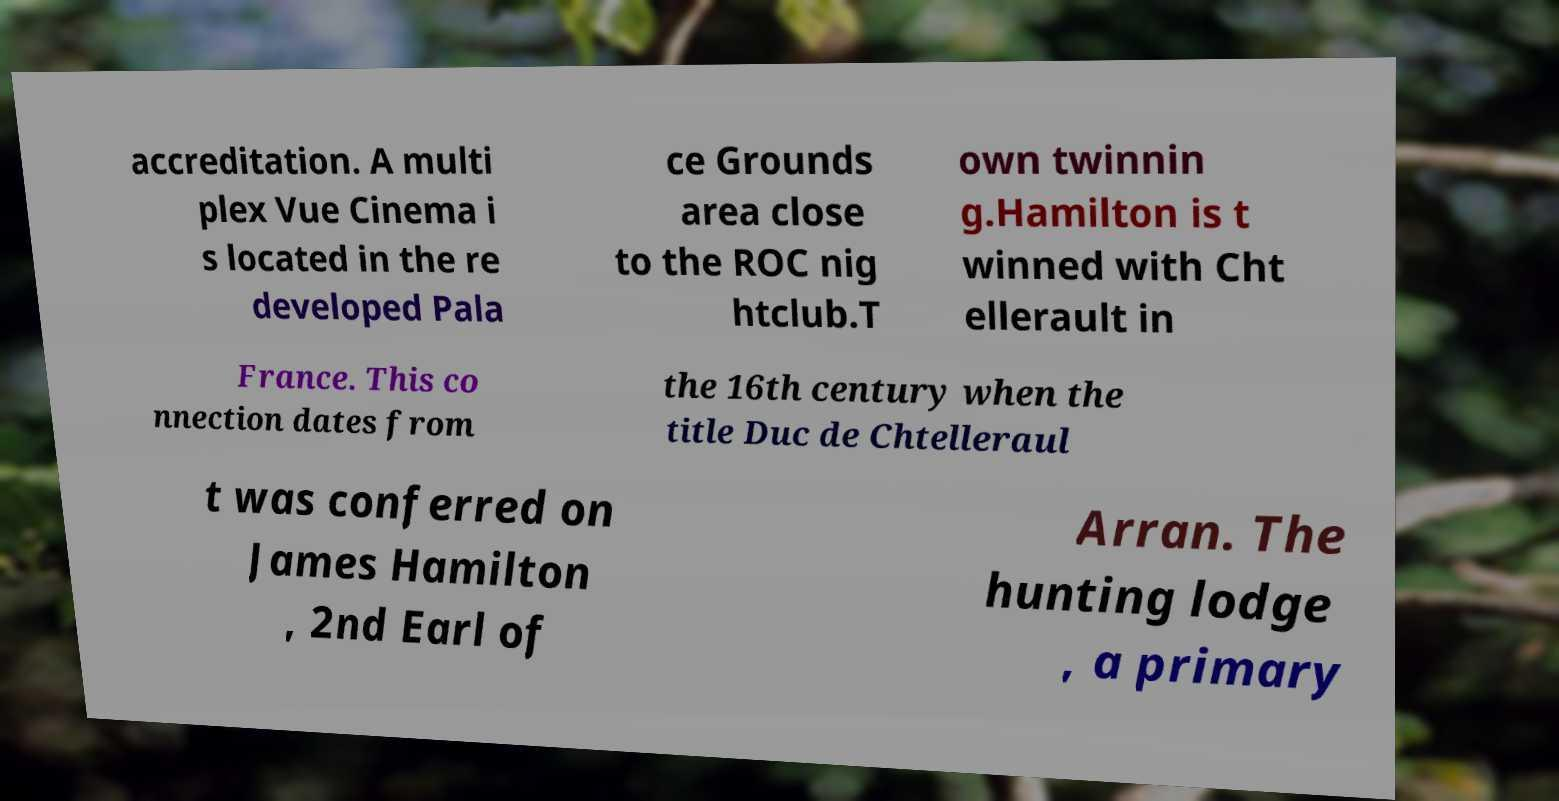Could you assist in decoding the text presented in this image and type it out clearly? accreditation. A multi plex Vue Cinema i s located in the re developed Pala ce Grounds area close to the ROC nig htclub.T own twinnin g.Hamilton is t winned with Cht ellerault in France. This co nnection dates from the 16th century when the title Duc de Chtelleraul t was conferred on James Hamilton , 2nd Earl of Arran. The hunting lodge , a primary 